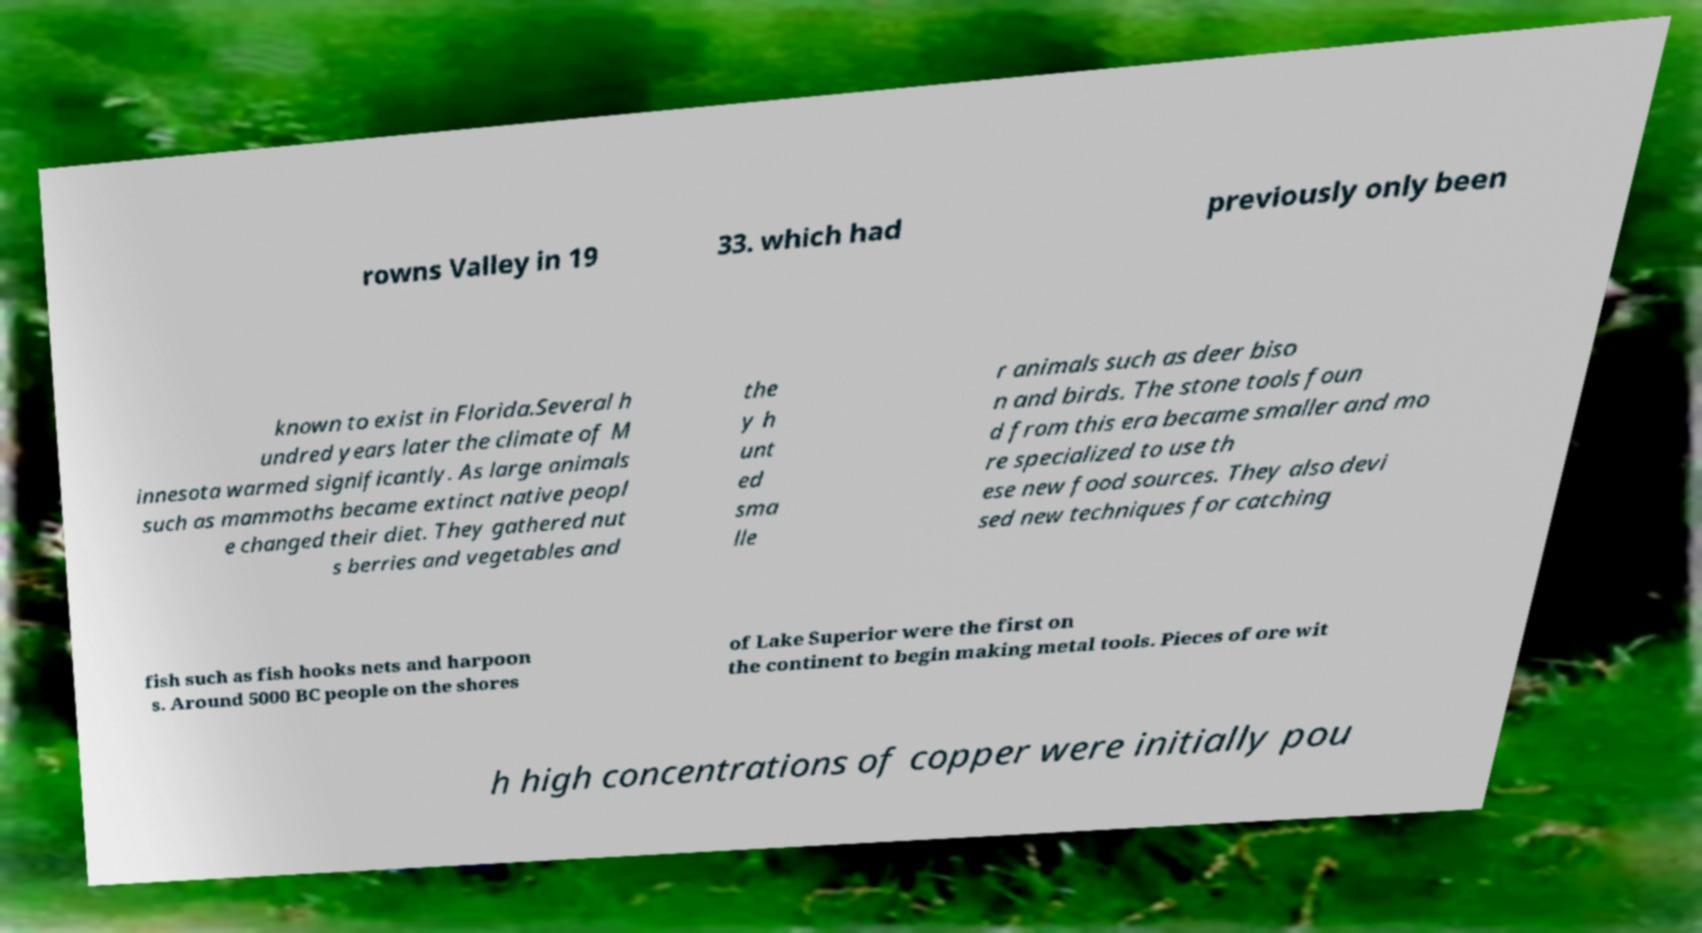There's text embedded in this image that I need extracted. Can you transcribe it verbatim? rowns Valley in 19 33. which had previously only been known to exist in Florida.Several h undred years later the climate of M innesota warmed significantly. As large animals such as mammoths became extinct native peopl e changed their diet. They gathered nut s berries and vegetables and the y h unt ed sma lle r animals such as deer biso n and birds. The stone tools foun d from this era became smaller and mo re specialized to use th ese new food sources. They also devi sed new techniques for catching fish such as fish hooks nets and harpoon s. Around 5000 BC people on the shores of Lake Superior were the first on the continent to begin making metal tools. Pieces of ore wit h high concentrations of copper were initially pou 